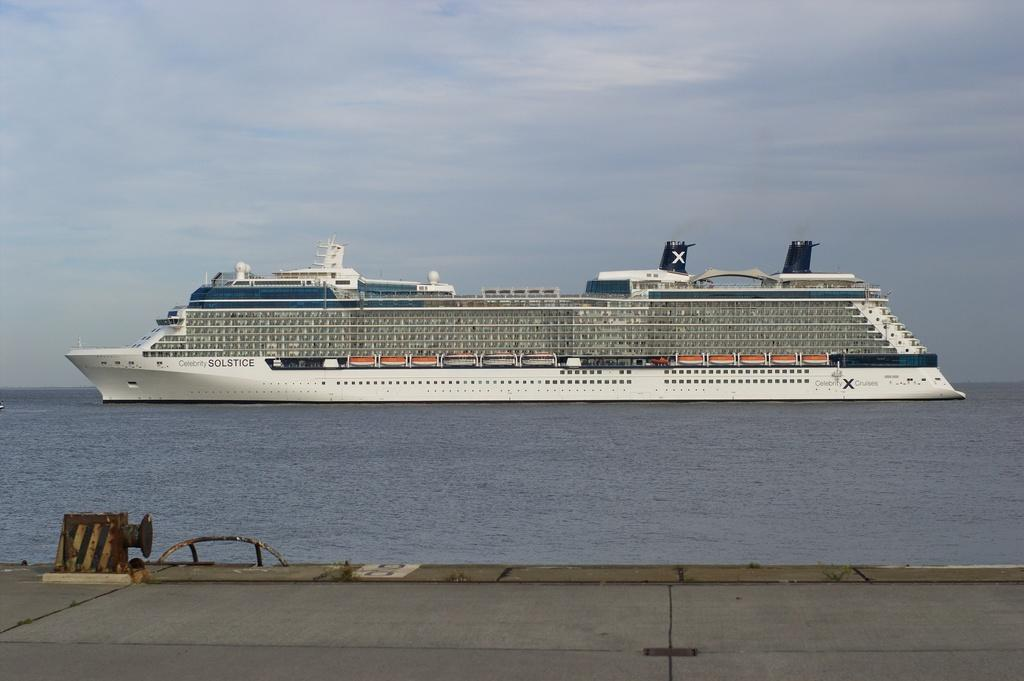What is the condition of the sky in the image? The sky is cloudy in the image. What can be seen in the water in the image? The provided facts do not mention anything specific about the water in the image. What type of vehicle is in the image? There is a ship in the image. What type of lettuce is being used as a basketball in the image? There is no lettuce or basketball present in the image. 